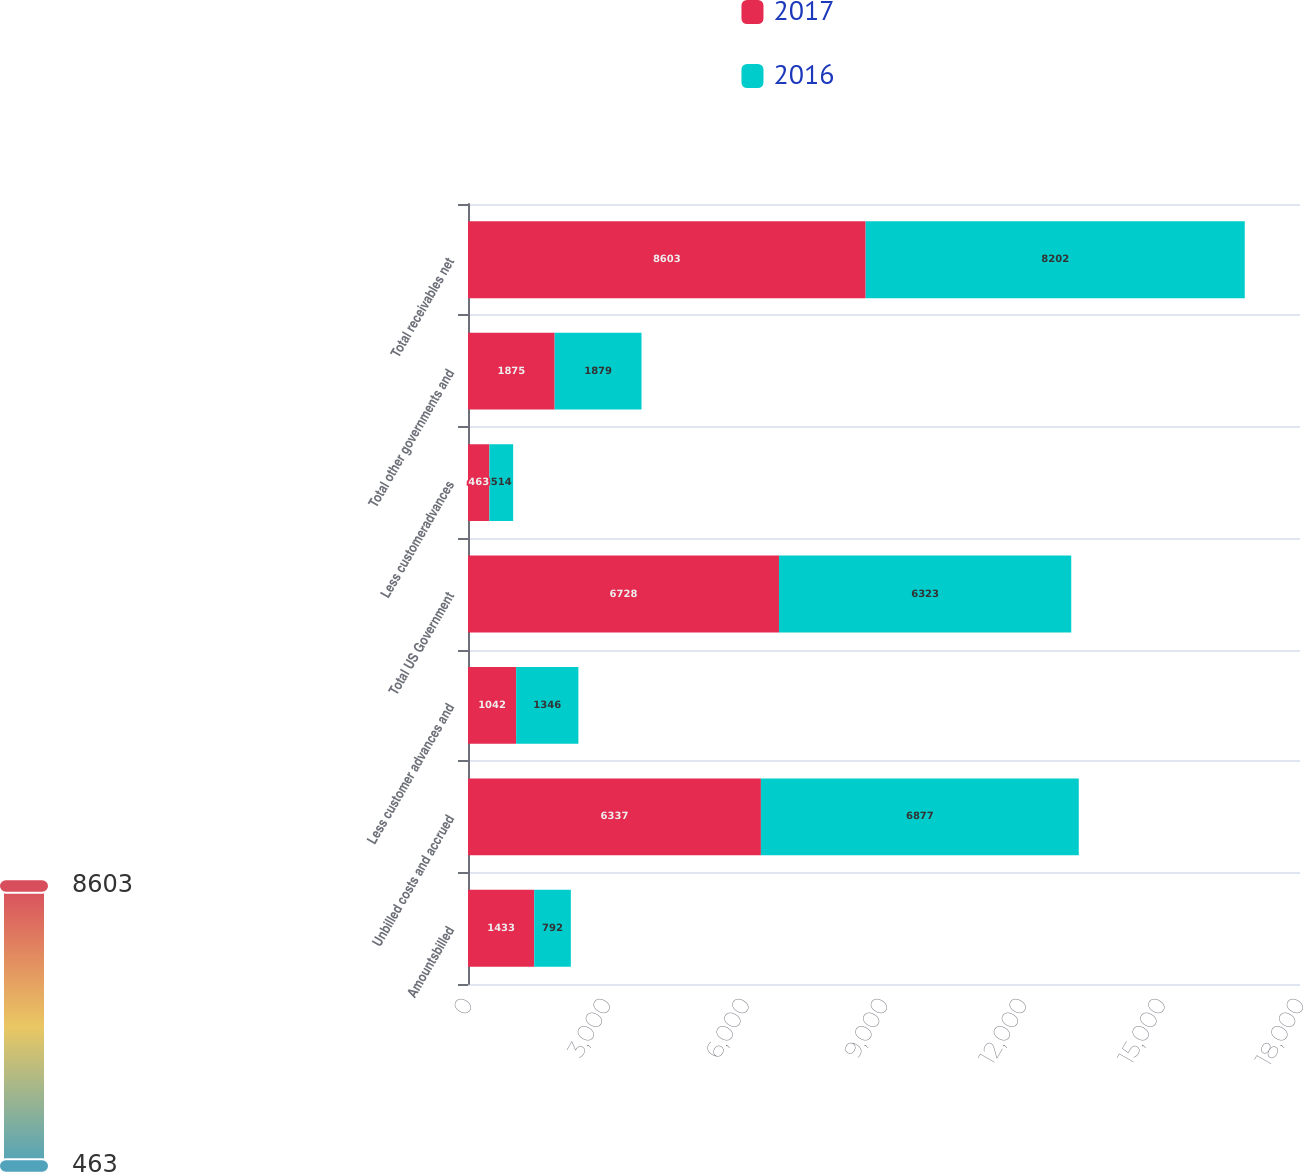<chart> <loc_0><loc_0><loc_500><loc_500><stacked_bar_chart><ecel><fcel>Amountsbilled<fcel>Unbilled costs and accrued<fcel>Less customer advances and<fcel>Total US Government<fcel>Less customeradvances<fcel>Total other governments and<fcel>Total receivables net<nl><fcel>2017<fcel>1433<fcel>6337<fcel>1042<fcel>6728<fcel>463<fcel>1875<fcel>8603<nl><fcel>2016<fcel>792<fcel>6877<fcel>1346<fcel>6323<fcel>514<fcel>1879<fcel>8202<nl></chart> 